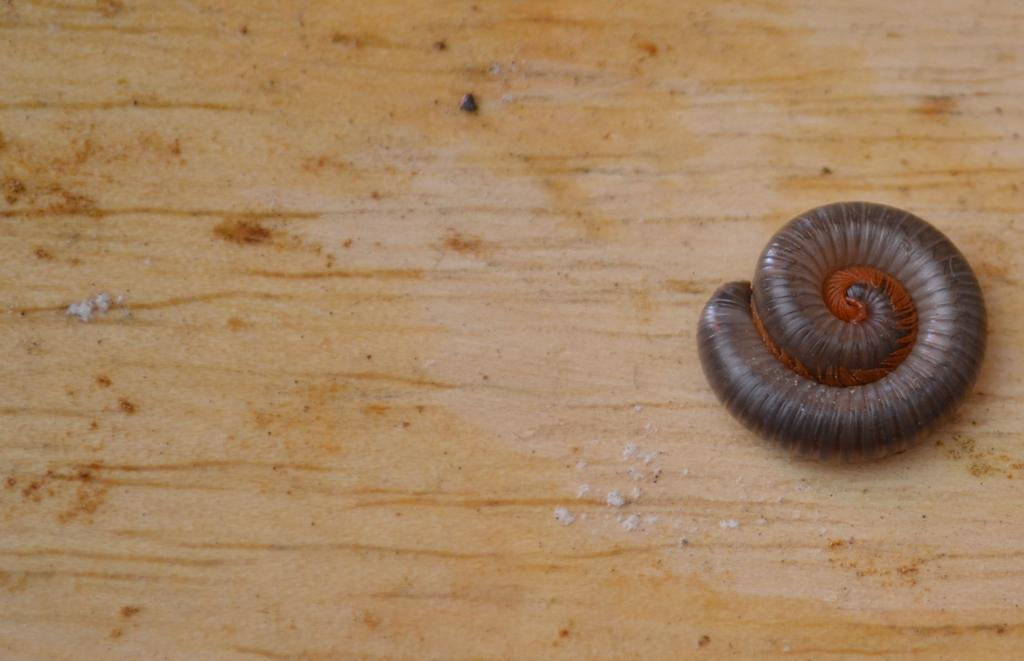What is placed on the floor in the image? There is an insert on the floor in the image. What type of news can be seen on the island in the image? There is no island or news present in the image; it only features an insert on the floor. 